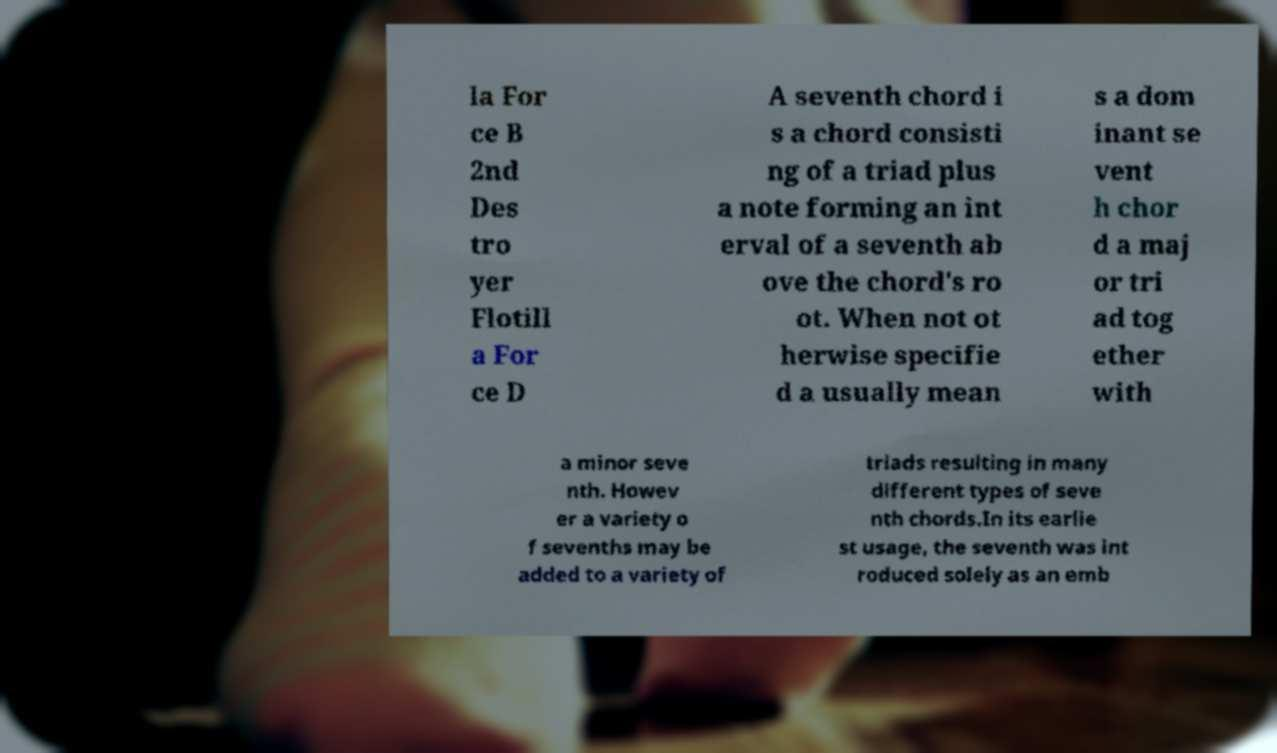There's text embedded in this image that I need extracted. Can you transcribe it verbatim? la For ce B 2nd Des tro yer Flotill a For ce D A seventh chord i s a chord consisti ng of a triad plus a note forming an int erval of a seventh ab ove the chord's ro ot. When not ot herwise specifie d a usually mean s a dom inant se vent h chor d a maj or tri ad tog ether with a minor seve nth. Howev er a variety o f sevenths may be added to a variety of triads resulting in many different types of seve nth chords.In its earlie st usage, the seventh was int roduced solely as an emb 